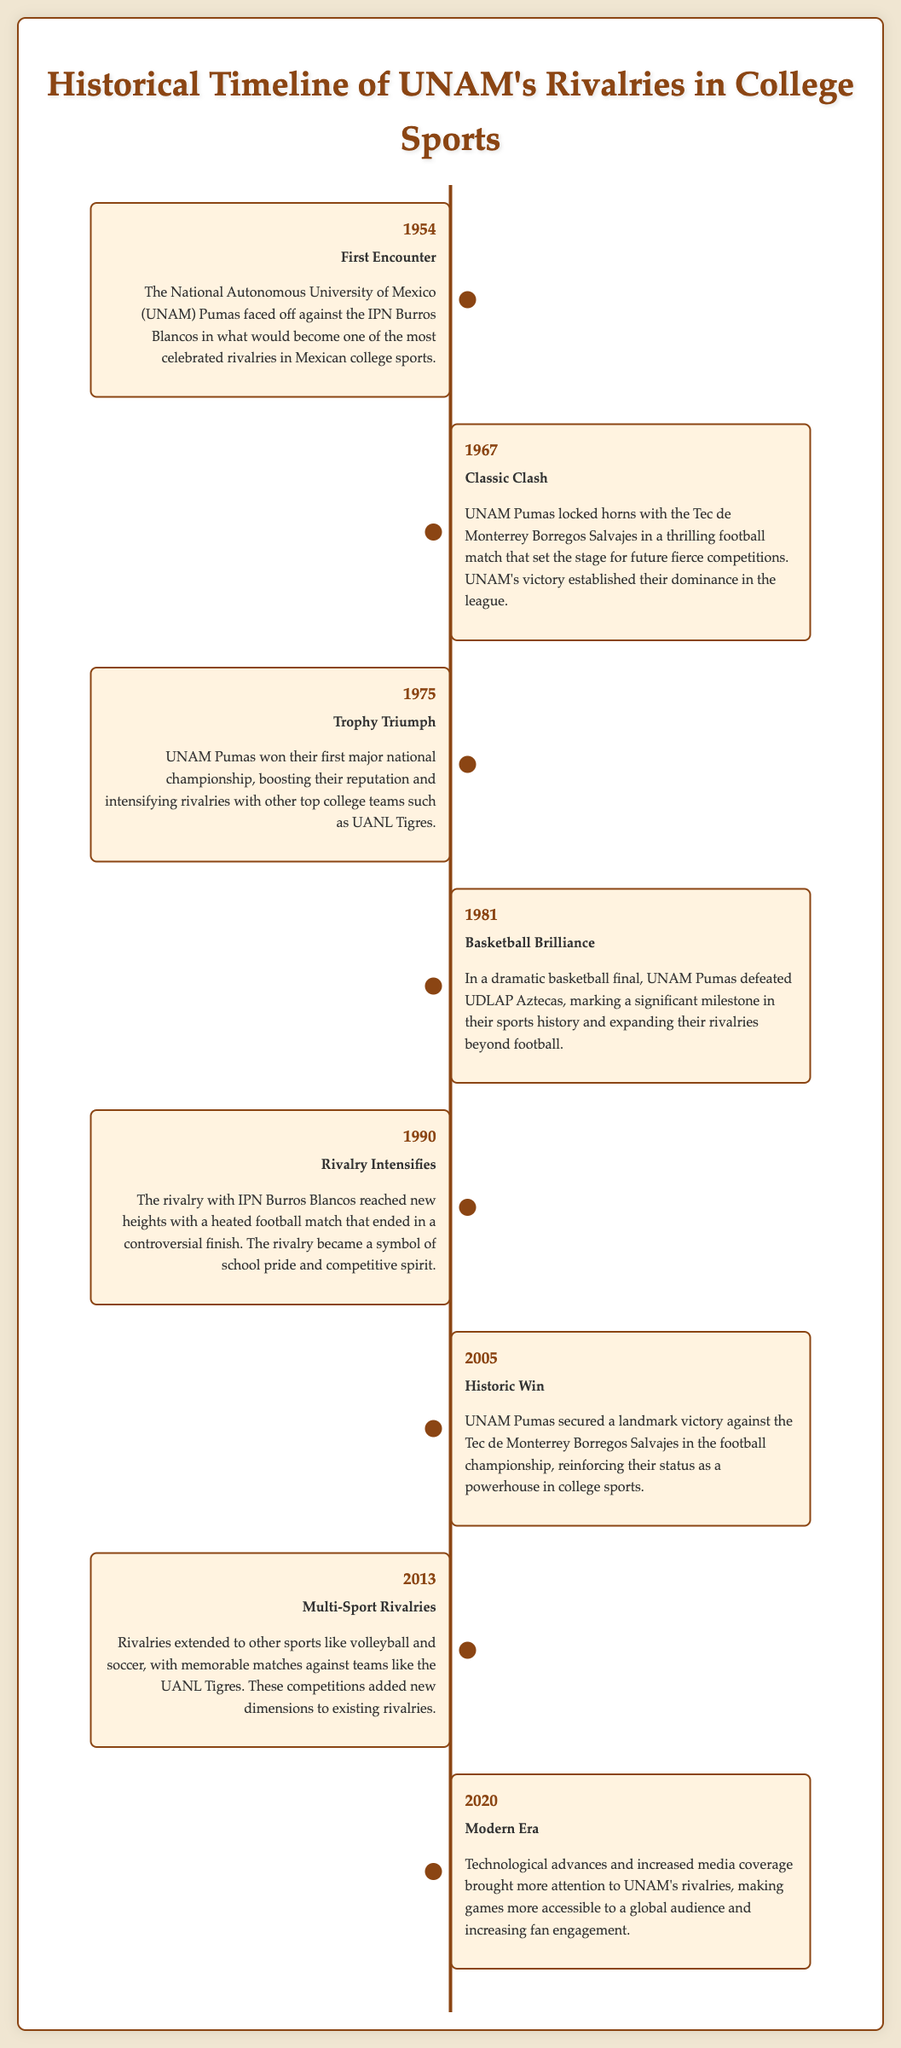What year was the first encounter between UNAM Pumas and IPN Burros Blancos? The first encounter is stated as occurring in 1954.
Answer: 1954 What event took place in 1975? The event mentioned for 1975 is the trophy won by UNAM Pumas, marking their first major national championship.
Answer: Trophy Triumph Which team did UNAM defeat in the 1981 basketball final? The document specifies that UNAM defeated UDLAP Aztecas in the 1981 basketball final.
Answer: UDLAP Aztecas What is significant about the year 2005 for UNAM? The year 2005 marks a historic win against the Tec de Monterrey Borregos Salvajes in the football championship.
Answer: Historic Win How did the rivalry with IPN Burros Blancos evolve in 1990? In 1990, the rivalry intensified, resulting in a heated football match with a controversial finish.
Answer: Rivalry Intensifies What impact did the year 2020 have on UNAM's rivalries? The year 2020 is when technological advances and increased media coverage brought more attention to UNAM's rivalries.
Answer: Modern Era In which year did rivalries extend to other sports? The document states that rivalries extended to other sports like volleyball and soccer in 2013.
Answer: 2013 What did the 1967 match with Tec de Monterrey signify? The 1967 match is described as a classic clash that established UNAM's dominance in the league.
Answer: Classic Clash 